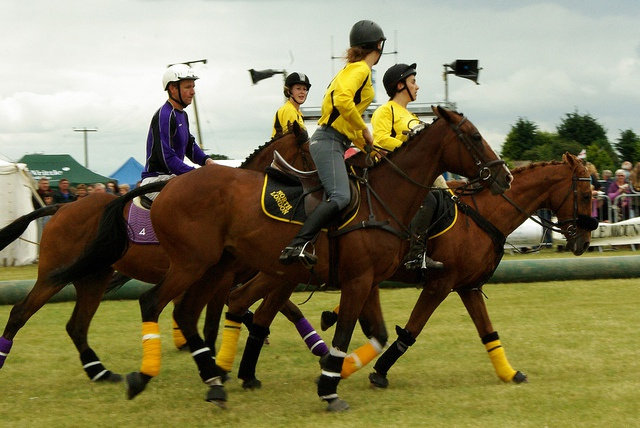Describe the objects in this image and their specific colors. I can see horse in ivory, black, maroon, olive, and orange tones, horse in ivory, black, maroon, and olive tones, horse in ivory, black, maroon, gray, and olive tones, people in ivory, black, gray, gold, and olive tones, and people in ivory, black, navy, and maroon tones in this image. 